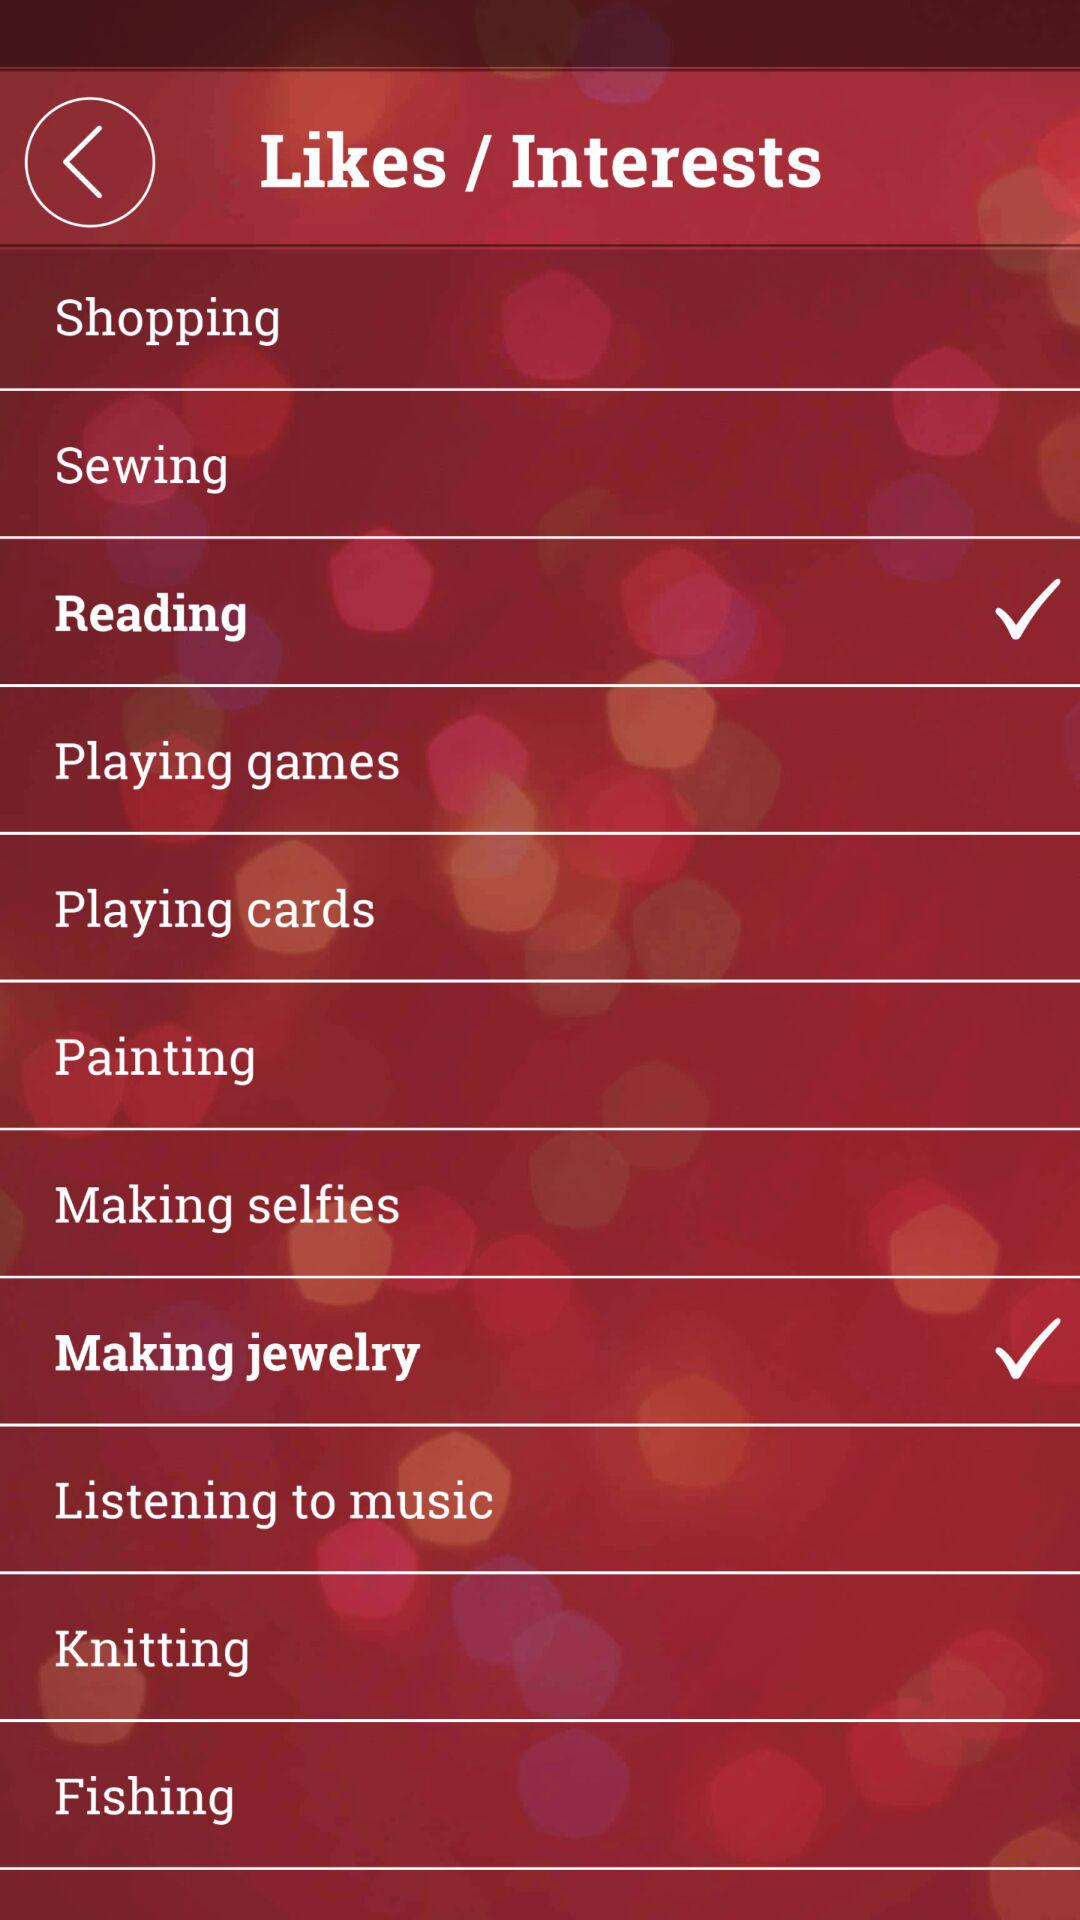How many interests have a check mark?
Answer the question using a single word or phrase. 2 